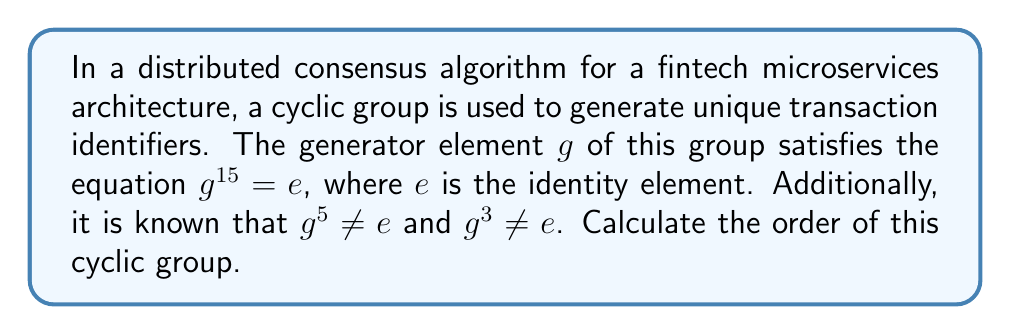Teach me how to tackle this problem. To solve this problem, we need to understand the concept of cyclic groups and their orders. In a cyclic group generated by an element $g$, the order of the group is the smallest positive integer $n$ such that $g^n = e$, where $e$ is the identity element.

Given information:
1. $g^{15} = e$
2. $g^5 \neq e$
3. $g^3 \neq e$

Step 1: Determine possible orders
The order of the group must be a divisor of 15, as $g^{15} = e$. The divisors of 15 are 1, 3, 5, and 15.

Step 2: Eliminate impossible orders
- Order cannot be 1, as $g \neq e$ (implied by $g^3 \neq e$ and $g^5 \neq e$)
- Order cannot be 3, as $g^3 \neq e$
- Order cannot be 5, as $g^5 \neq e$

Step 3: Conclude the order
By process of elimination, the only remaining possibility is that the order of the group is 15.

This makes sense in the context of a distributed consensus algorithm for a fintech microservices architecture, as a larger order provides more unique identifiers before cycling, which is beneficial for scalability and resilience in transaction processing.
Answer: The order of the cyclic group is 15. 